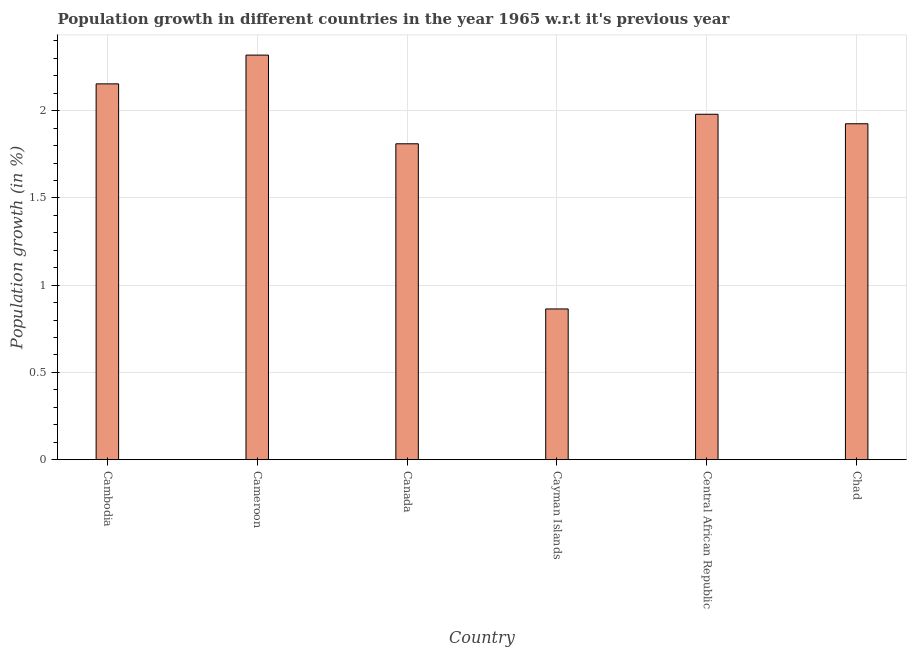Does the graph contain grids?
Give a very brief answer. Yes. What is the title of the graph?
Offer a very short reply. Population growth in different countries in the year 1965 w.r.t it's previous year. What is the label or title of the X-axis?
Offer a very short reply. Country. What is the label or title of the Y-axis?
Ensure brevity in your answer.  Population growth (in %). What is the population growth in Cayman Islands?
Provide a short and direct response. 0.86. Across all countries, what is the maximum population growth?
Offer a very short reply. 2.32. Across all countries, what is the minimum population growth?
Keep it short and to the point. 0.86. In which country was the population growth maximum?
Keep it short and to the point. Cameroon. In which country was the population growth minimum?
Provide a succinct answer. Cayman Islands. What is the sum of the population growth?
Give a very brief answer. 11.05. What is the difference between the population growth in Cameroon and Cayman Islands?
Provide a short and direct response. 1.45. What is the average population growth per country?
Ensure brevity in your answer.  1.84. What is the median population growth?
Make the answer very short. 1.95. What is the ratio of the population growth in Cameroon to that in Chad?
Provide a succinct answer. 1.2. Is the population growth in Cameroon less than that in Canada?
Offer a very short reply. No. Is the difference between the population growth in Canada and Chad greater than the difference between any two countries?
Give a very brief answer. No. What is the difference between the highest and the second highest population growth?
Make the answer very short. 0.17. What is the difference between the highest and the lowest population growth?
Your answer should be compact. 1.45. How many bars are there?
Offer a very short reply. 6. Are all the bars in the graph horizontal?
Your answer should be very brief. No. How many countries are there in the graph?
Offer a terse response. 6. Are the values on the major ticks of Y-axis written in scientific E-notation?
Make the answer very short. No. What is the Population growth (in %) of Cambodia?
Provide a succinct answer. 2.15. What is the Population growth (in %) of Cameroon?
Provide a succinct answer. 2.32. What is the Population growth (in %) of Canada?
Provide a short and direct response. 1.81. What is the Population growth (in %) in Cayman Islands?
Offer a very short reply. 0.86. What is the Population growth (in %) of Central African Republic?
Your answer should be very brief. 1.98. What is the Population growth (in %) of Chad?
Give a very brief answer. 1.92. What is the difference between the Population growth (in %) in Cambodia and Cameroon?
Your response must be concise. -0.16. What is the difference between the Population growth (in %) in Cambodia and Canada?
Keep it short and to the point. 0.34. What is the difference between the Population growth (in %) in Cambodia and Cayman Islands?
Provide a short and direct response. 1.29. What is the difference between the Population growth (in %) in Cambodia and Central African Republic?
Keep it short and to the point. 0.17. What is the difference between the Population growth (in %) in Cambodia and Chad?
Ensure brevity in your answer.  0.23. What is the difference between the Population growth (in %) in Cameroon and Canada?
Provide a succinct answer. 0.51. What is the difference between the Population growth (in %) in Cameroon and Cayman Islands?
Provide a succinct answer. 1.45. What is the difference between the Population growth (in %) in Cameroon and Central African Republic?
Your response must be concise. 0.34. What is the difference between the Population growth (in %) in Cameroon and Chad?
Ensure brevity in your answer.  0.39. What is the difference between the Population growth (in %) in Canada and Cayman Islands?
Make the answer very short. 0.95. What is the difference between the Population growth (in %) in Canada and Central African Republic?
Ensure brevity in your answer.  -0.17. What is the difference between the Population growth (in %) in Canada and Chad?
Your answer should be very brief. -0.11. What is the difference between the Population growth (in %) in Cayman Islands and Central African Republic?
Your response must be concise. -1.12. What is the difference between the Population growth (in %) in Cayman Islands and Chad?
Your answer should be compact. -1.06. What is the difference between the Population growth (in %) in Central African Republic and Chad?
Provide a short and direct response. 0.05. What is the ratio of the Population growth (in %) in Cambodia to that in Cameroon?
Your answer should be very brief. 0.93. What is the ratio of the Population growth (in %) in Cambodia to that in Canada?
Your answer should be compact. 1.19. What is the ratio of the Population growth (in %) in Cambodia to that in Cayman Islands?
Your answer should be very brief. 2.49. What is the ratio of the Population growth (in %) in Cambodia to that in Central African Republic?
Your answer should be very brief. 1.09. What is the ratio of the Population growth (in %) in Cambodia to that in Chad?
Provide a succinct answer. 1.12. What is the ratio of the Population growth (in %) in Cameroon to that in Canada?
Your answer should be very brief. 1.28. What is the ratio of the Population growth (in %) in Cameroon to that in Cayman Islands?
Provide a short and direct response. 2.68. What is the ratio of the Population growth (in %) in Cameroon to that in Central African Republic?
Your response must be concise. 1.17. What is the ratio of the Population growth (in %) in Cameroon to that in Chad?
Provide a succinct answer. 1.2. What is the ratio of the Population growth (in %) in Canada to that in Cayman Islands?
Make the answer very short. 2.1. What is the ratio of the Population growth (in %) in Canada to that in Central African Republic?
Your answer should be compact. 0.92. What is the ratio of the Population growth (in %) in Cayman Islands to that in Central African Republic?
Make the answer very short. 0.44. What is the ratio of the Population growth (in %) in Cayman Islands to that in Chad?
Keep it short and to the point. 0.45. What is the ratio of the Population growth (in %) in Central African Republic to that in Chad?
Your answer should be compact. 1.03. 